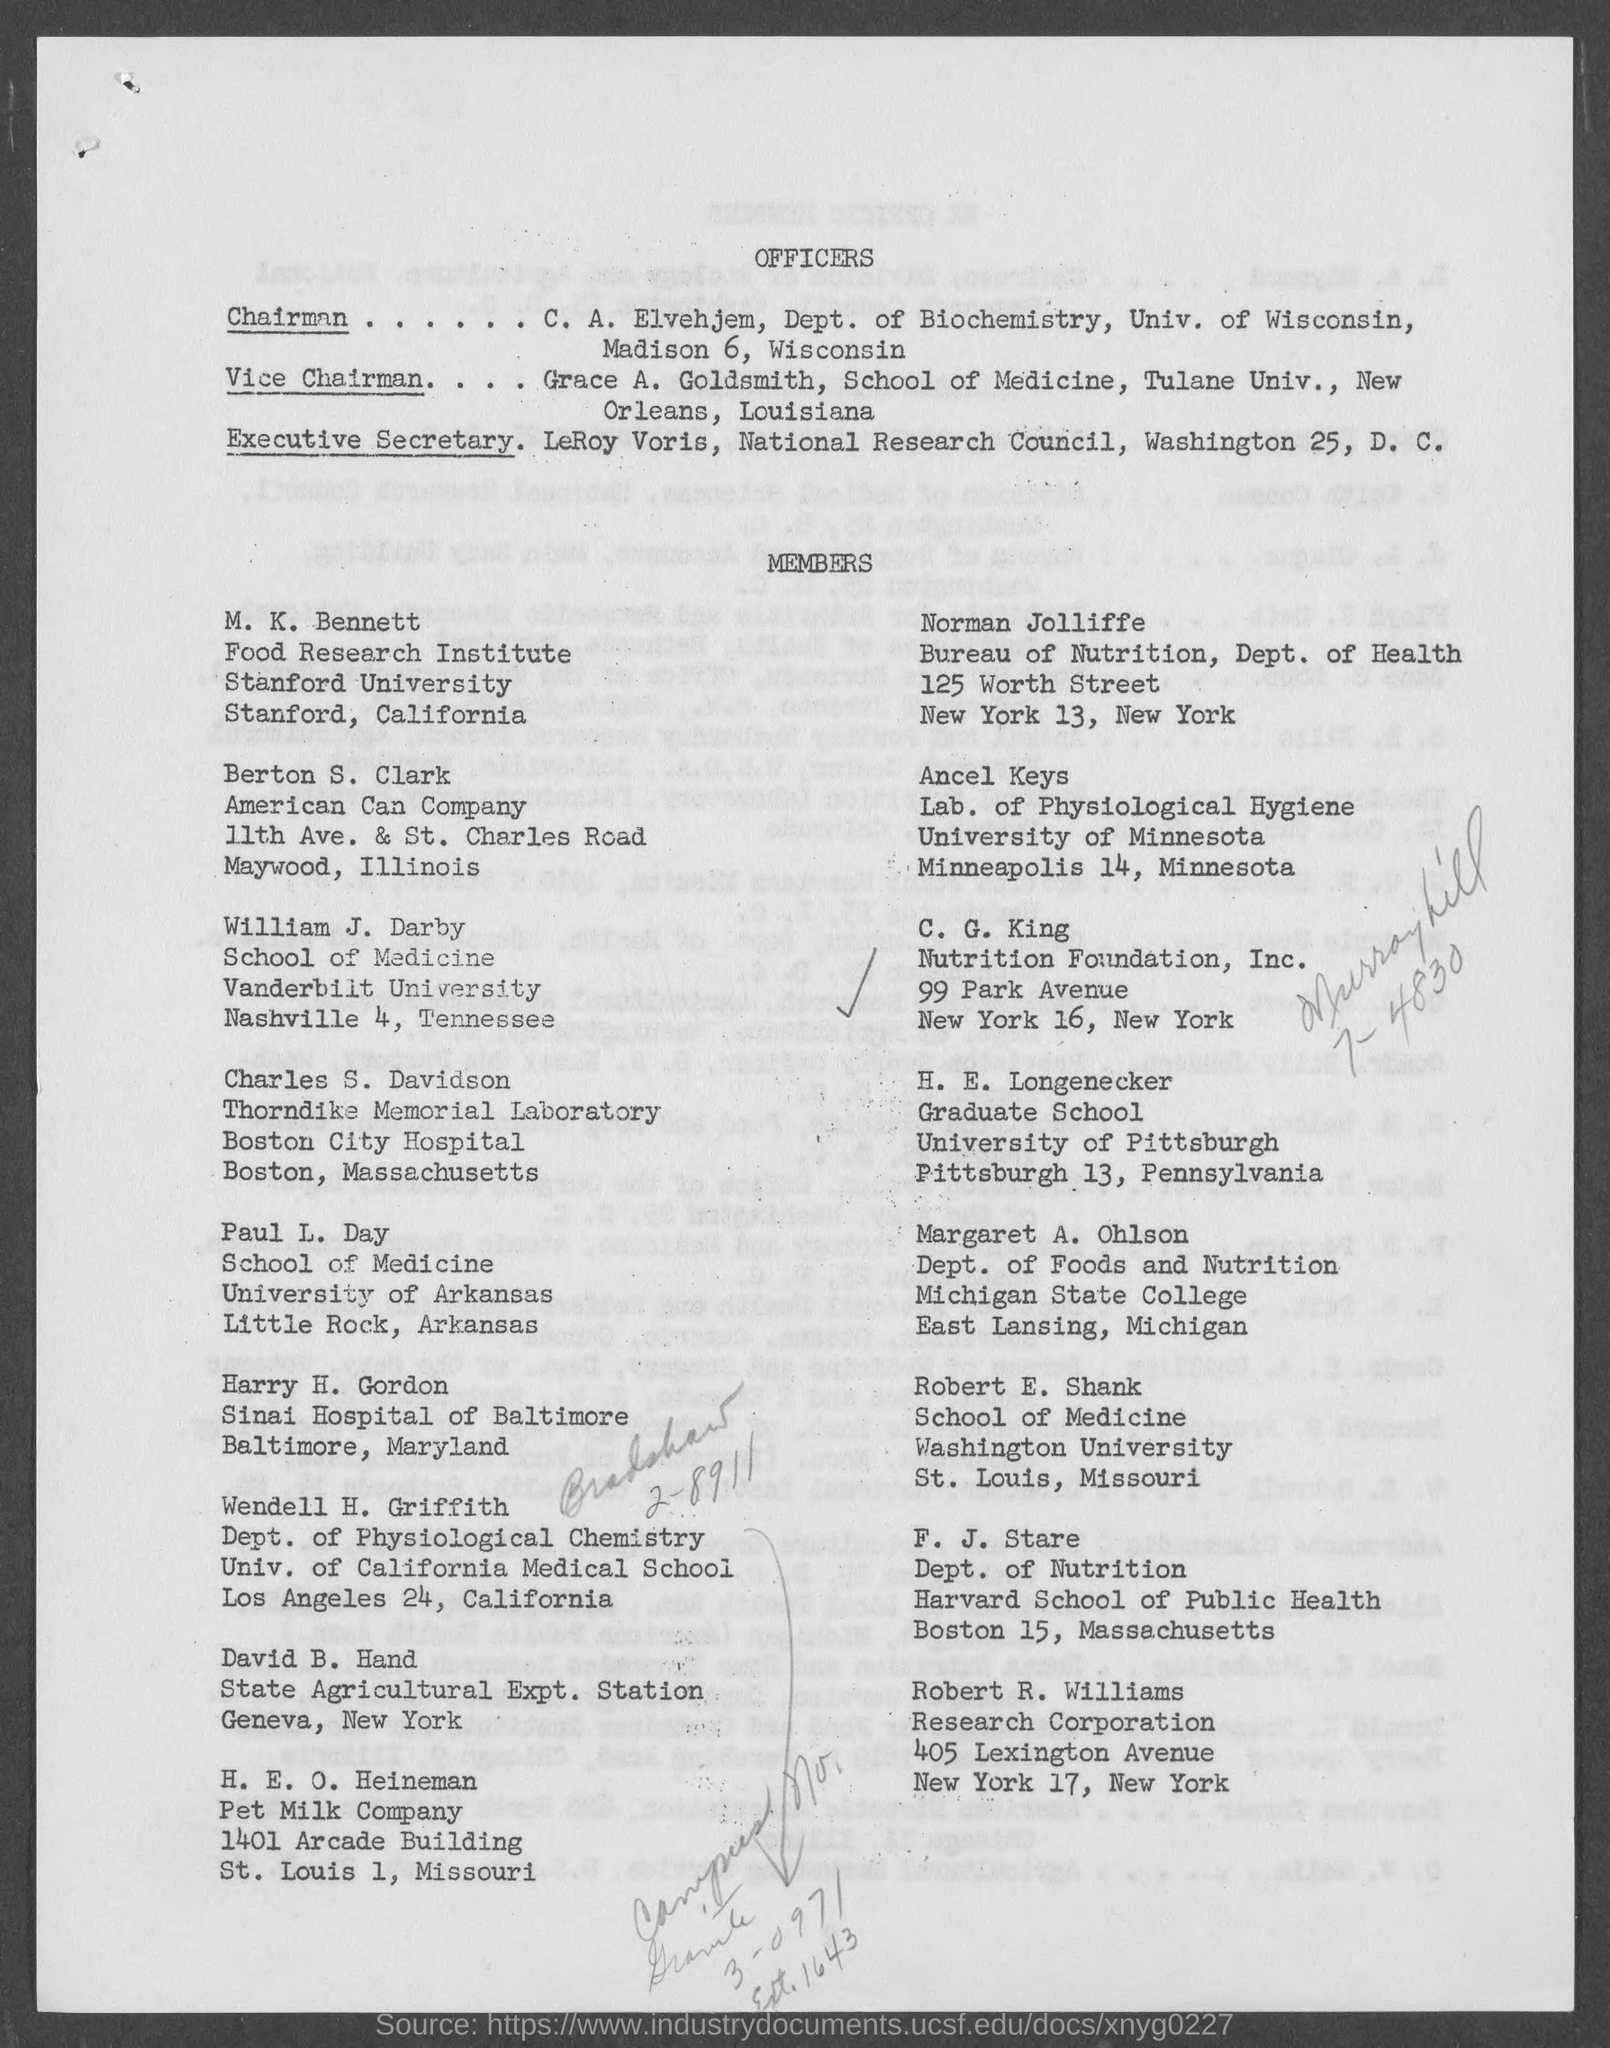Towhich depat. c. a. elvehjem belongs to ?
Provide a succinct answer. DEPT. OF BIOCHEMISTRY. What is  the name of the vice chairman mentioned in the given page ?
Offer a terse response. Grace a. goldsmith. What is the designation of leroy voris as mentioned in the given page ?
Provide a short and direct response. Executive secretary. To which institute m.k. bennett belongs to ?
Your answer should be very brief. Food research institute. To which dept. norman jolliffe belongs to as mentioned in the given page ?
Keep it short and to the point. Dept. of health. To which company berton s. clerk belongs to ?
Offer a very short reply. American can company. To which university william j. darby belongs to ?
Ensure brevity in your answer.  VANDERBILT UNIVERSITY. To which university h.e. longenecker belongs to ?
Your answer should be compact. UNIVERSITY OF PITTSBURGH. To which dept. f.j. stare belongs to ?
Provide a succinct answer. Dept. of nutrition. To which university robert e.shank belongs to ?
Your answer should be very brief. Washington university. 